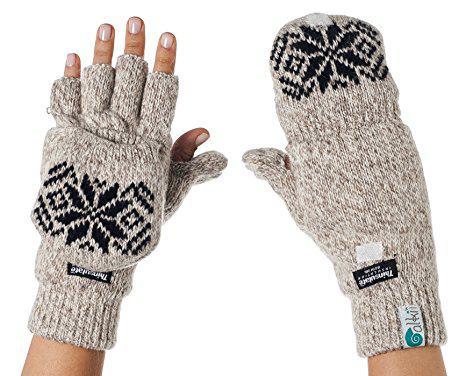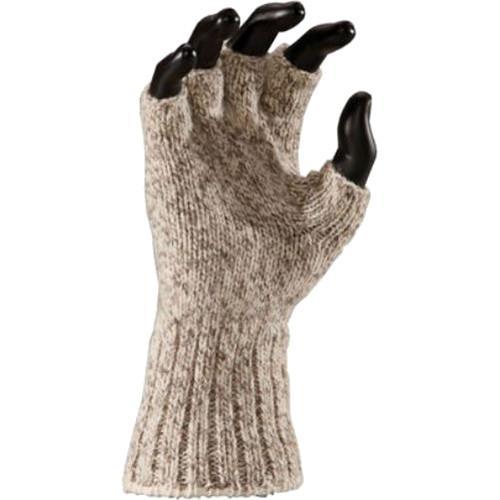The first image is the image on the left, the second image is the image on the right. Evaluate the accuracy of this statement regarding the images: "Each image shows a complete pair of mittens.". Is it true? Answer yes or no. No. The first image is the image on the left, the second image is the image on the right. Evaluate the accuracy of this statement regarding the images: "An image shows one fingerless glove over black """"fingers"""".". Is it true? Answer yes or no. Yes. 